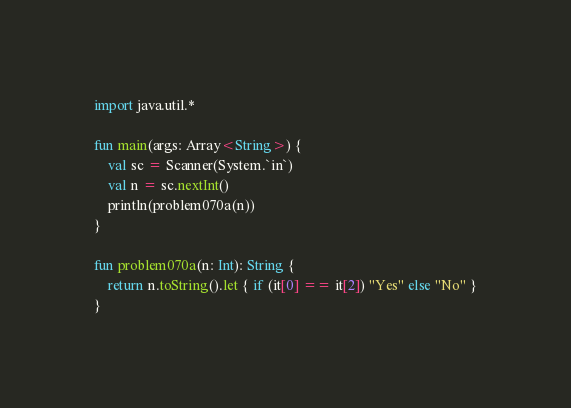<code> <loc_0><loc_0><loc_500><loc_500><_Kotlin_>import java.util.*

fun main(args: Array<String>) {
    val sc = Scanner(System.`in`)
    val n = sc.nextInt()
    println(problem070a(n))
}

fun problem070a(n: Int): String {
    return n.toString().let { if (it[0] == it[2]) "Yes" else "No" }
}</code> 